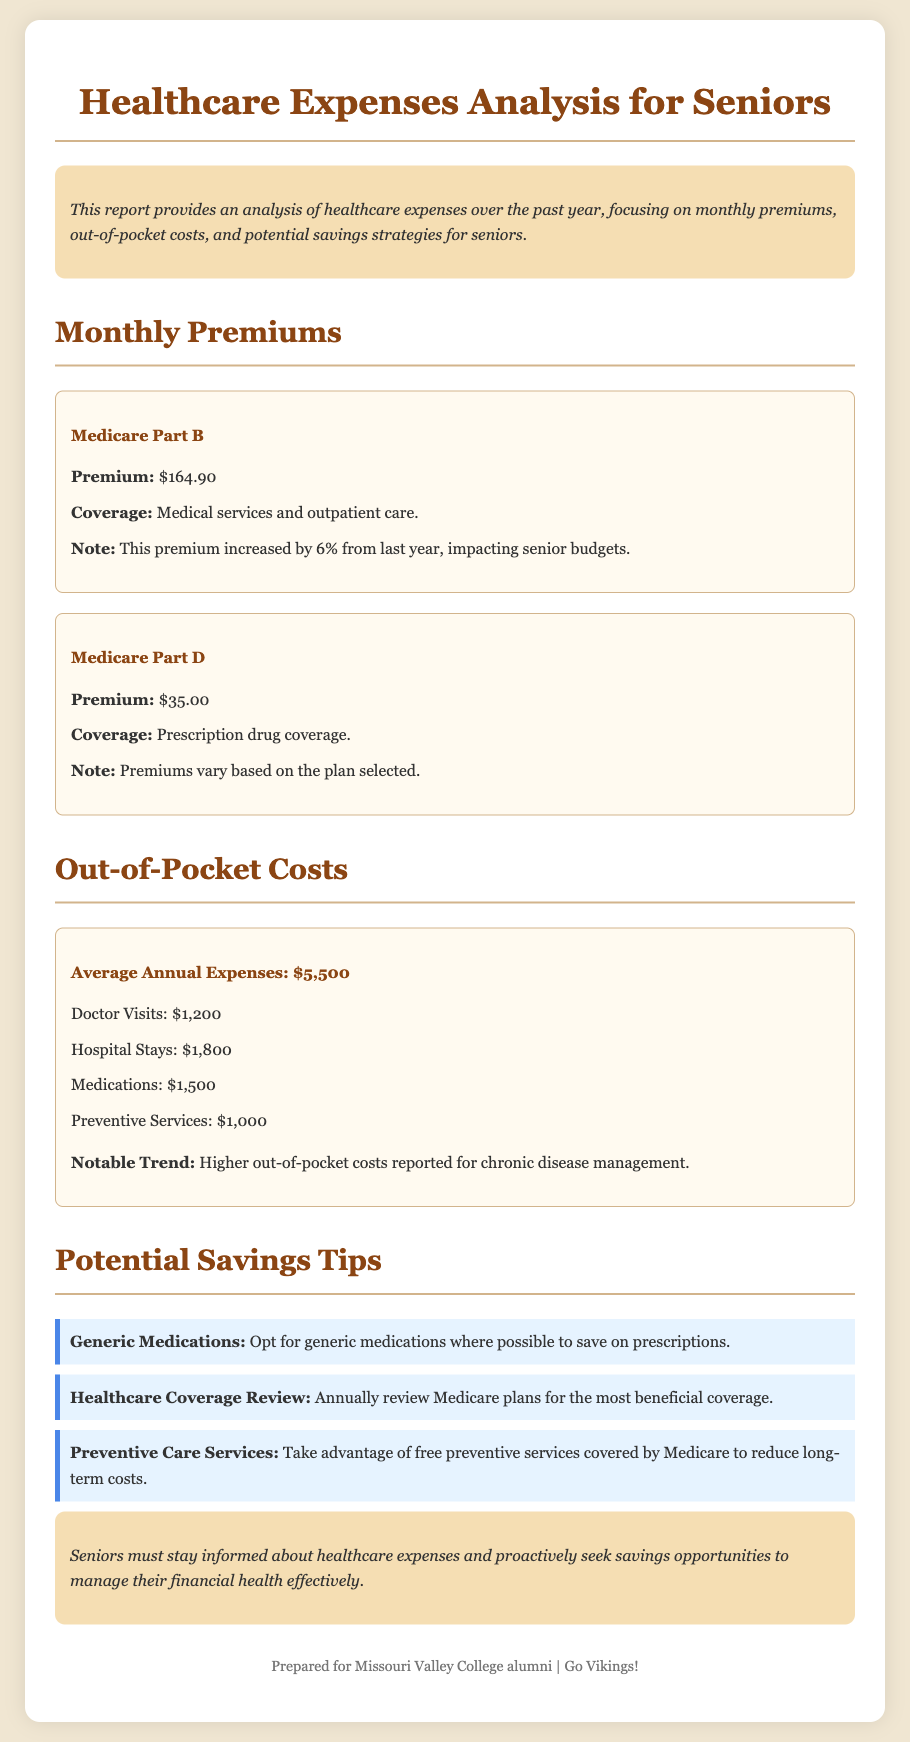what is the premium for Medicare Part B? The document states the premium for Medicare Part B is $164.90.
Answer: $164.90 what is the average annual out-of-pocket expense? The average annual out-of-pocket expense mentioned in the document is $5,500.
Answer: $5,500 how much does a senior typically spend on medications annually? According to the document, the typical annual expense on medications is $1,500.
Answer: $1,500 what is one potential savings tip provided for seniors? The document suggests opting for generic medications as a potential savings tip for seniors.
Answer: Generic Medications which preventive service is emphasized to help reduce long-term costs? The document emphasizes taking advantage of free preventive services covered by Medicare.
Answer: Preventive Care Services by what percentage did the Medicare Part B premium increase? The increase in the Medicare Part B premium from last year is stated to be 6%.
Answer: 6% what is the total cost of doctor visits as mentioned in the report? The cost of doctor visits stated in the report is $1,200.
Answer: $1,200 what should seniors do annually regarding their Medicare plans? The document recommends seniors to review Medicare plans annually for the most beneficial coverage.
Answer: Healthcare Coverage Review what notable trend is mentioned regarding out-of-pocket costs? The notable trend mentioned is that higher out-of-pocket costs are reported for chronic disease management.
Answer: Chronic disease management 